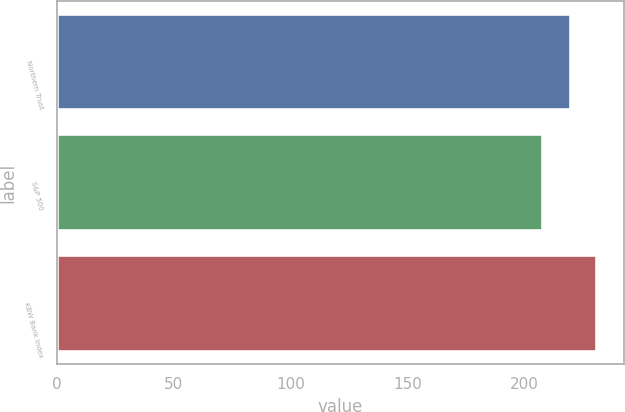Convert chart. <chart><loc_0><loc_0><loc_500><loc_500><bar_chart><fcel>Northern Trust<fcel>S&P 500<fcel>KBW Bank Index<nl><fcel>220<fcel>208<fcel>231<nl></chart> 